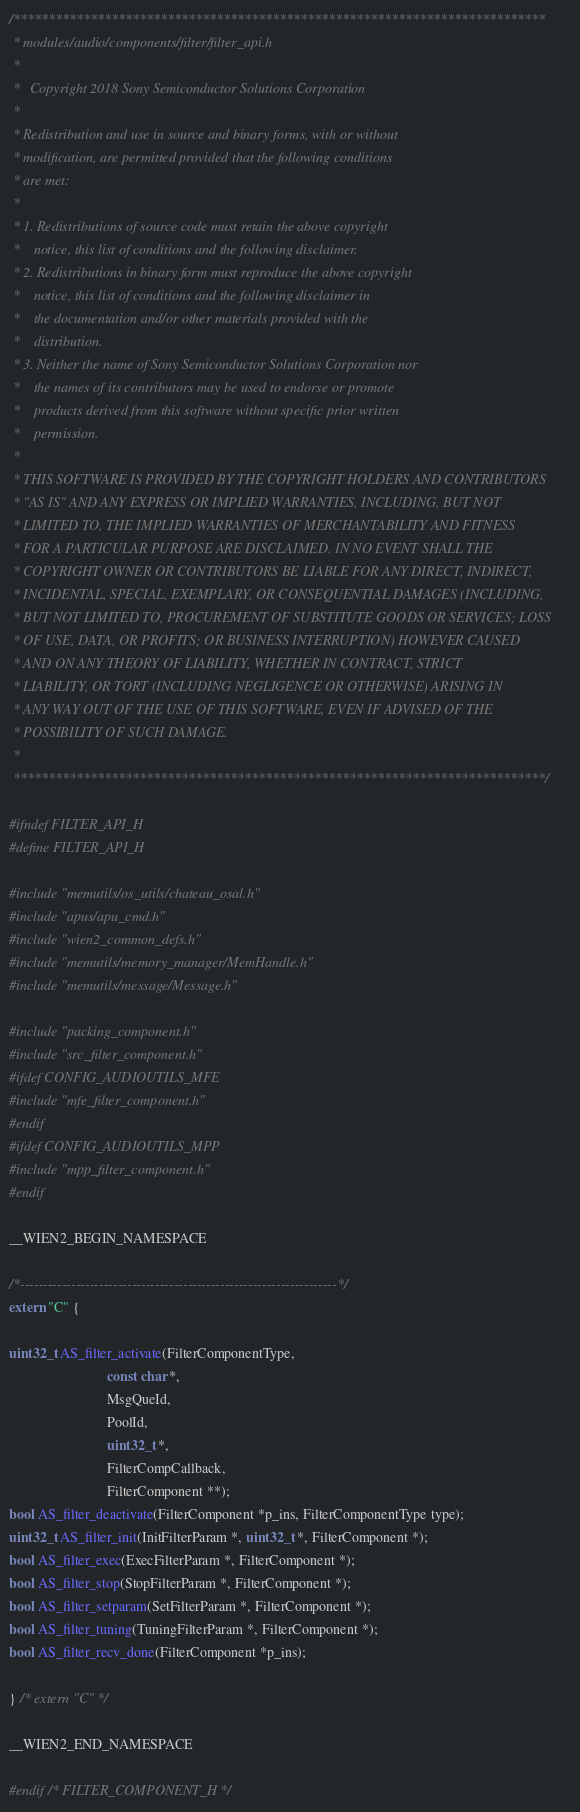<code> <loc_0><loc_0><loc_500><loc_500><_C_>/****************************************************************************
 * modules/audio/components/filter/filter_api.h
 *
 *   Copyright 2018 Sony Semiconductor Solutions Corporation
 *
 * Redistribution and use in source and binary forms, with or without
 * modification, are permitted provided that the following conditions
 * are met:
 *
 * 1. Redistributions of source code must retain the above copyright
 *    notice, this list of conditions and the following disclaimer.
 * 2. Redistributions in binary form must reproduce the above copyright
 *    notice, this list of conditions and the following disclaimer in
 *    the documentation and/or other materials provided with the
 *    distribution.
 * 3. Neither the name of Sony Semiconductor Solutions Corporation nor
 *    the names of its contributors may be used to endorse or promote
 *    products derived from this software without specific prior written
 *    permission.
 *
 * THIS SOFTWARE IS PROVIDED BY THE COPYRIGHT HOLDERS AND CONTRIBUTORS
 * "AS IS" AND ANY EXPRESS OR IMPLIED WARRANTIES, INCLUDING, BUT NOT
 * LIMITED TO, THE IMPLIED WARRANTIES OF MERCHANTABILITY AND FITNESS
 * FOR A PARTICULAR PURPOSE ARE DISCLAIMED. IN NO EVENT SHALL THE
 * COPYRIGHT OWNER OR CONTRIBUTORS BE LIABLE FOR ANY DIRECT, INDIRECT,
 * INCIDENTAL, SPECIAL, EXEMPLARY, OR CONSEQUENTIAL DAMAGES (INCLUDING,
 * BUT NOT LIMITED TO, PROCUREMENT OF SUBSTITUTE GOODS OR SERVICES; LOSS
 * OF USE, DATA, OR PROFITS; OR BUSINESS INTERRUPTION) HOWEVER CAUSED
 * AND ON ANY THEORY OF LIABILITY, WHETHER IN CONTRACT, STRICT
 * LIABILITY, OR TORT (INCLUDING NEGLIGENCE OR OTHERWISE) ARISING IN
 * ANY WAY OUT OF THE USE OF THIS SOFTWARE, EVEN IF ADVISED OF THE
 * POSSIBILITY OF SUCH DAMAGE.
 *
 ****************************************************************************/

#ifndef FILTER_API_H
#define FILTER_API_H

#include "memutils/os_utils/chateau_osal.h"
#include "apus/apu_cmd.h"
#include "wien2_common_defs.h"
#include "memutils/memory_manager/MemHandle.h"
#include "memutils/message/Message.h"

#include "packing_component.h"
#include "src_filter_component.h"
#ifdef CONFIG_AUDIOUTILS_MFE
#include "mfe_filter_component.h"
#endif
#ifdef CONFIG_AUDIOUTILS_MPP
#include "mpp_filter_component.h"
#endif

__WIEN2_BEGIN_NAMESPACE

/*--------------------------------------------------------------------*/
extern "C" {

uint32_t AS_filter_activate(FilterComponentType,
                            const char *,
                            MsgQueId,
                            PoolId,
                            uint32_t *,
                            FilterCompCallback,
                            FilterComponent **);
bool AS_filter_deactivate(FilterComponent *p_ins, FilterComponentType type);
uint32_t AS_filter_init(InitFilterParam *, uint32_t *, FilterComponent *);
bool AS_filter_exec(ExecFilterParam *, FilterComponent *);
bool AS_filter_stop(StopFilterParam *, FilterComponent *);
bool AS_filter_setparam(SetFilterParam *, FilterComponent *);
bool AS_filter_tuning(TuningFilterParam *, FilterComponent *);
bool AS_filter_recv_done(FilterComponent *p_ins);

} /* extern "C" */

__WIEN2_END_NAMESPACE

#endif /* FILTER_COMPONENT_H */
</code> 